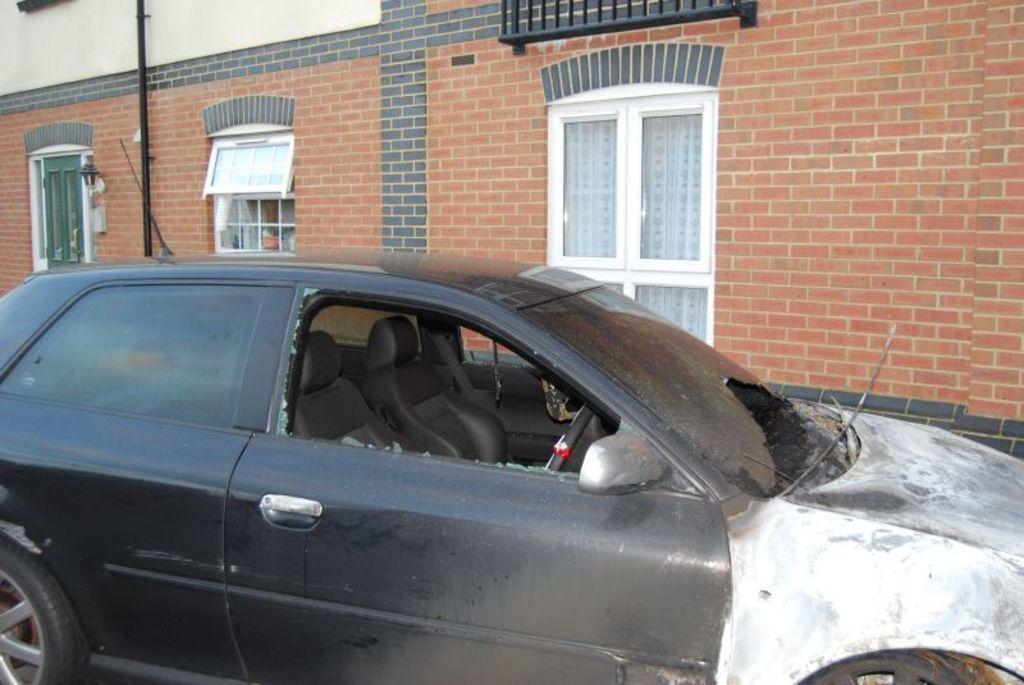Describe this image in one or two sentences. Building with windows. In-front of this building there is a pole and black vehicle. 